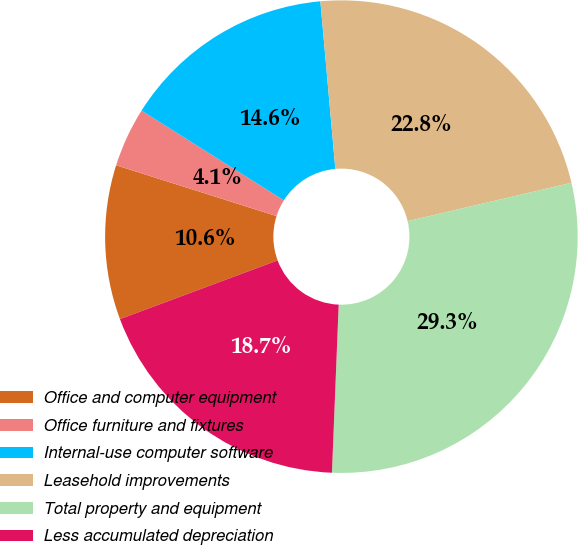Convert chart. <chart><loc_0><loc_0><loc_500><loc_500><pie_chart><fcel>Office and computer equipment<fcel>Office furniture and fixtures<fcel>Internal-use computer software<fcel>Leasehold improvements<fcel>Total property and equipment<fcel>Less accumulated depreciation<nl><fcel>10.56%<fcel>4.07%<fcel>14.63%<fcel>22.76%<fcel>29.3%<fcel>18.69%<nl></chart> 